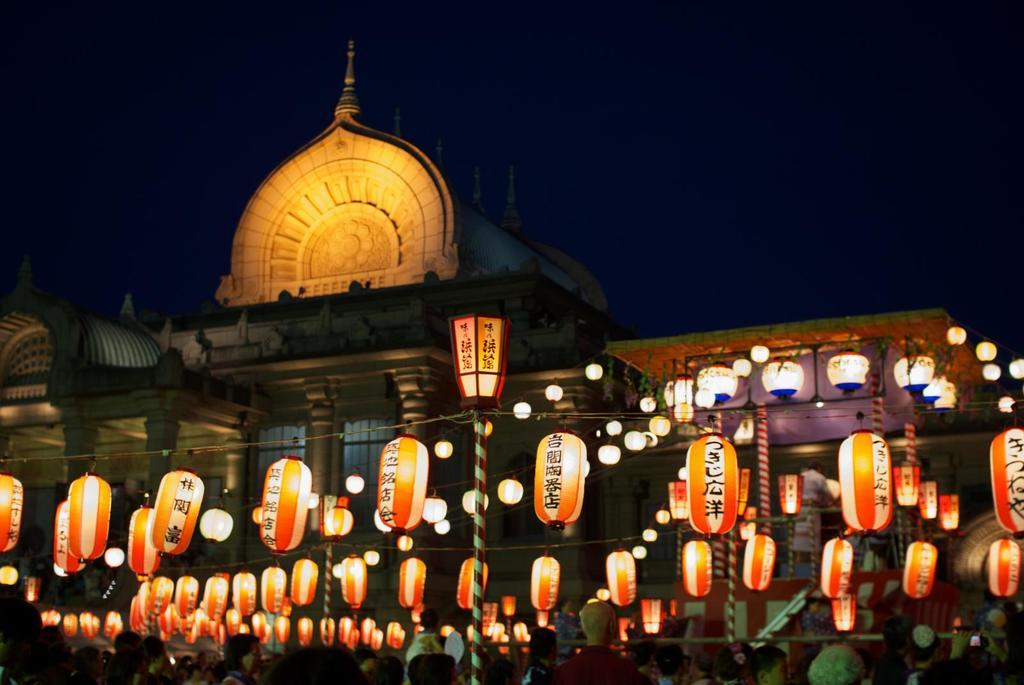What can be seen hanging between poles in the foreground of the image? There are lanterns hanging in between poles in the foreground of the image. What is located at the bottom part of the image? There are persons in the bottom part of the image. What type of structure can be seen in the background of the image? There is a building in the background of the image. How would you describe the sky in the background of the image? The sky is dark in the background of the image. How many birds are sitting on the persons' shoulders in the image? There are no birds present in the image; it features lanterns hanging between poles, persons, a building, and a dark sky. What type of coat is the person wearing in the image? There is no information about a coat in the image; it only mentions the presence of persons in the bottom part of the image. 